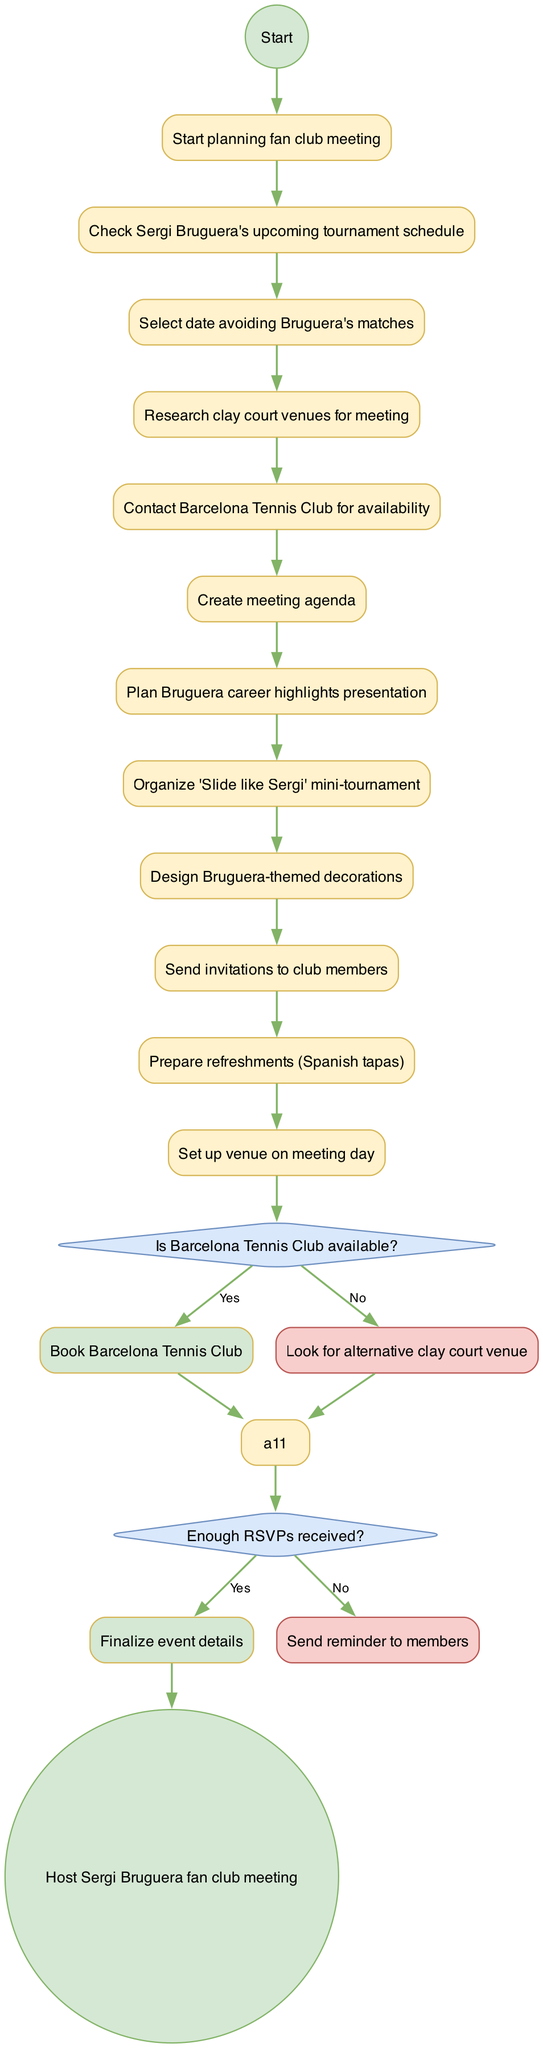What is the first activity in the diagram? The first activity listed after the initial node is "Check Sergi Bruguera's upcoming tournament schedule". This can be traced directly from the initial node leading to the first activity node.
Answer: Check Sergi Bruguera's upcoming tournament schedule How many total activities are there in the diagram? Counting each listed activity, there is a total of 10 activities, starting from the first one up to the last one before the decisions.
Answer: 10 What is the condition for the first decision in the diagram? The first decision node checks "Is Barcelona Tennis Club available?". This can be identified by reading the decision condition prominently displayed in a diamond-shaped node after the activities.
Answer: Is Barcelona Tennis Club available? If the answer to the decision about the Barcelona Tennis Club is yes, what is the next step? If the answer is yes, the next step is "Book Barcelona Tennis Club". This is directly linked as the succeeding action from the "Yes" path of that decision node.
Answer: Book Barcelona Tennis Club What happens if not enough RSVPs are received? If not enough RSVPs are received, then "Send reminder to members" is the next step to take, as indicated under the "No" path of the second decision node.
Answer: Send reminder to members After the decision about RSVPs, what is the next action if enough RSVPs are gathered? If enough RSVPs are received, then the diagram indicates to "Finalize event details" as the next action to be taken, found under the "Yes" path of the second decision node.
Answer: Finalize event details Which activity involves designing decorations? The "Design Bruguera-themed decorations" activity involves designing decorations. This is one of the listed activities shown in the diagram.
Answer: Design Bruguera-themed decorations How many decision nodes are present in the diagram? There are 2 decision nodes present in the diagram, indicated by the diamond shapes in the flow. Each decision leads to different paths based on the conditions evaluated.
Answer: 2 What is the final outcome of the activity diagram? The final outcome, indicated after the end of the flow, is "Host Sergi Bruguera fan club meeting". This summarizes the ultimate goal of all the activities and decisions in the diagram.
Answer: Host Sergi Bruguera fan club meeting 